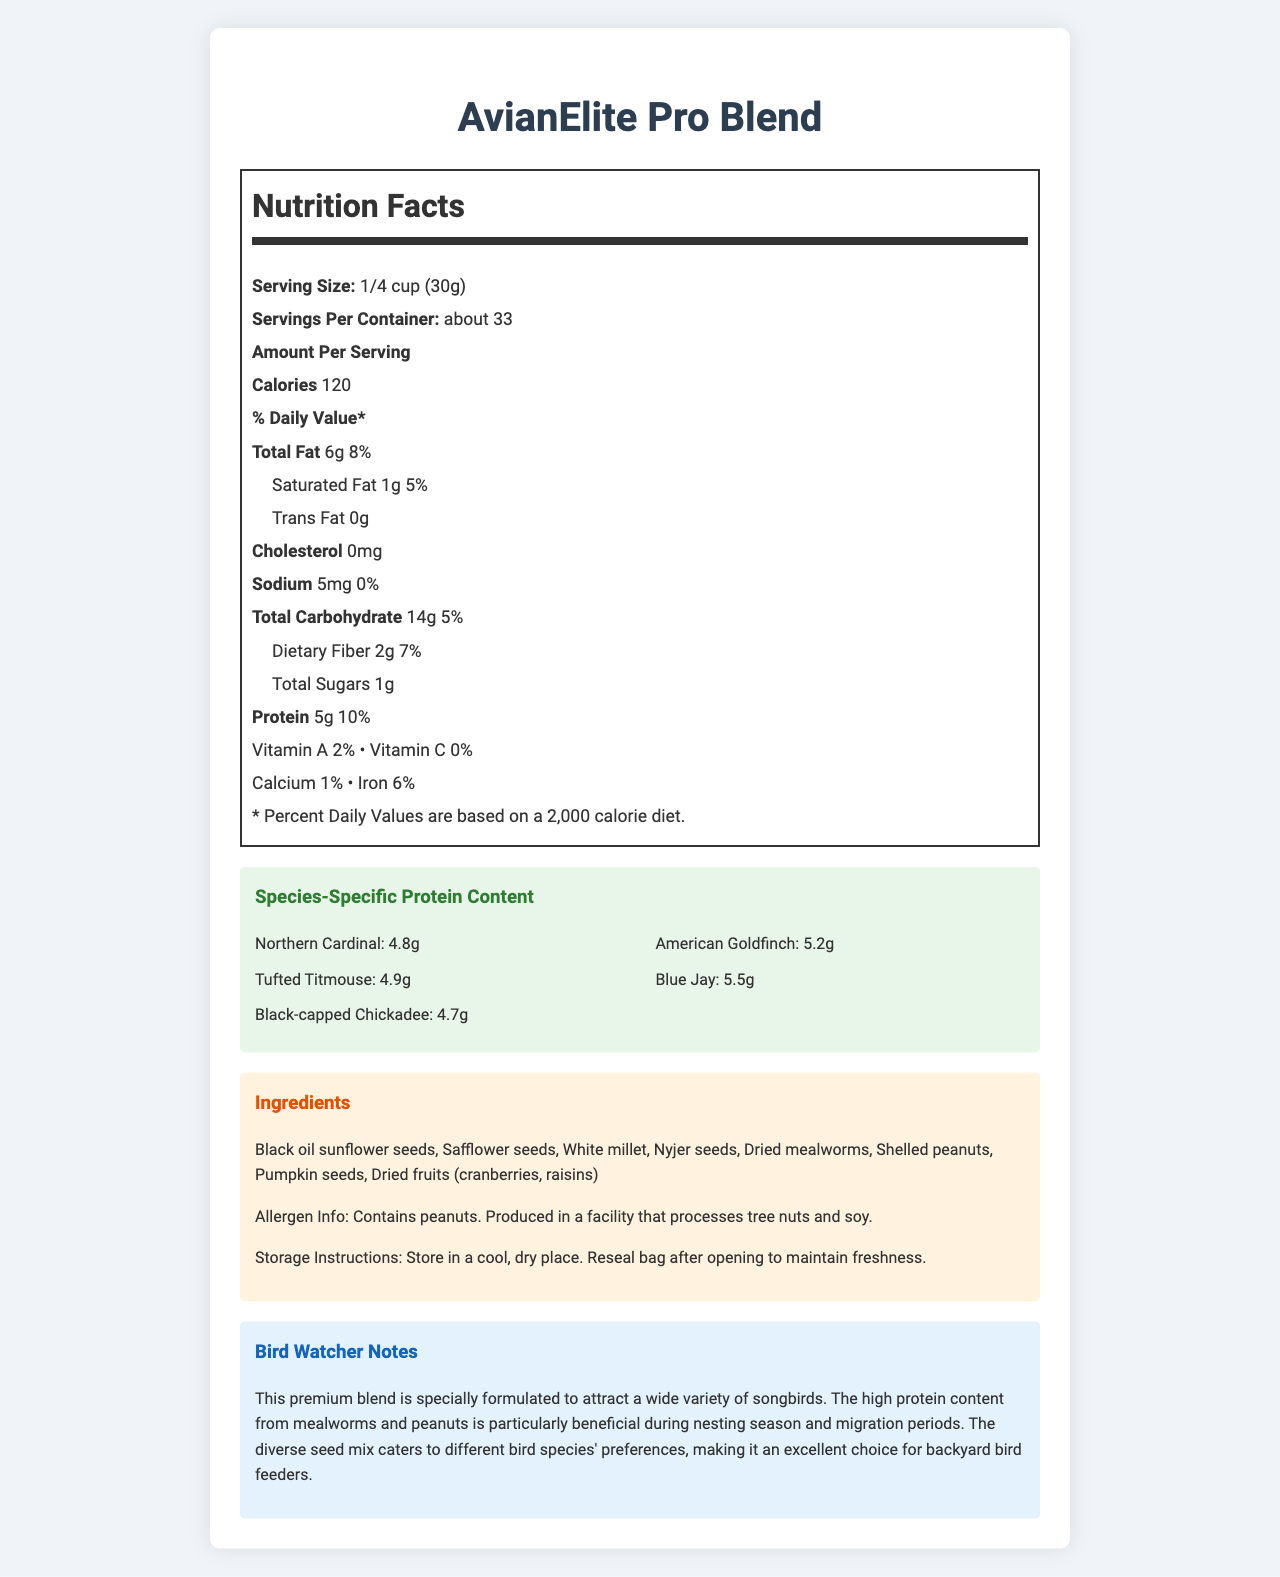What is the serving size of the AvianElite Pro Blend? The serving size is listed as 1/4 cup (30g) in the Nutrition Facts section.
Answer: 1/4 cup (30g) How many calories are there per serving? The number of calories per serving is 120, which is stated in the Amount Per Serving section.
Answer: 120 calories Which seed is listed first in the ingredients? The first ingredient listed is Black oil sunflower seeds in the Ingredients section.
Answer: Black oil sunflower seeds What is the percent daily value of iron per serving? The Nutrition Facts section states that the percent daily value of iron per serving is 6%.
Answer: 6% How much protein does a Blue Jay get per serving? The Species-Specific Protein Content section mentions that a Blue Jay gets 5.5g of protein per serving.
Answer: 5.5g Which of these birds receives the highest protein content per serving? A. Northern Cardinal B. American Goldfinch C. Blue Jay The Blue Jay receives 5.5g of protein per serving, the highest among the listed species.
Answer: C. Blue Jay What is the total fat content per serving? A. 4g B. 6g C. 8g According to the Nutrition Facts section, the total fat content per serving is 6g.
Answer: B. 6g Does this birdseed mix contain any tree nuts or soy? The Allergen Info mentions that the product is produced in a facility that processes tree nuts and soy.
Answer: Yes Does this product provide any vitamin C? The Nutrition Facts section shows 0% daily value for vitamin C, indicating no vitamin C content.
Answer: No Summarize the main idea of the document. The document highlights the nutritional components and specifics of AvianElite Pro Blend birdseed mix, including its suitability for various bird species and its special benefits during nesting and migration periods.
Answer: The document provides the nutritional information for AvianElite Pro Blend birdseed mix, highlighting its calories, macronutrients, micronutrients, ingredients, species-specific protein content, allergen information, storage instructions, and descriptive notes related to birdwatching. What is the ecological benefit during nesting season mentioned in the bird watcher notes? The bird watcher notes explain that the high protein content, particularly from mealworms and peanuts, is beneficial during nesting season and migration periods.
Answer: High protein content from mealworms and peanuts is beneficial How many servings are there in one container of AvianElite Pro Blend? The Nutrition Facts section states that there are about 33 servings per container.
Answer: About 33 What type of bird receives less than 5g of protein per serving? According to the Species-Specific Protein Content section, the Northern Cardinal receives 4.8g of protein, which is less than 5g.
Answer: Northern Cardinal What should you do to maintain the freshness of the birdseed? The Storage Instructions indicate that the bag should be resealed after opening to maintain freshness.
Answer: Reseal bag after opening Is this product suitable for parrots? The document does not provide specific information on whether this product is suitable for parrots.
Answer: Not enough information 